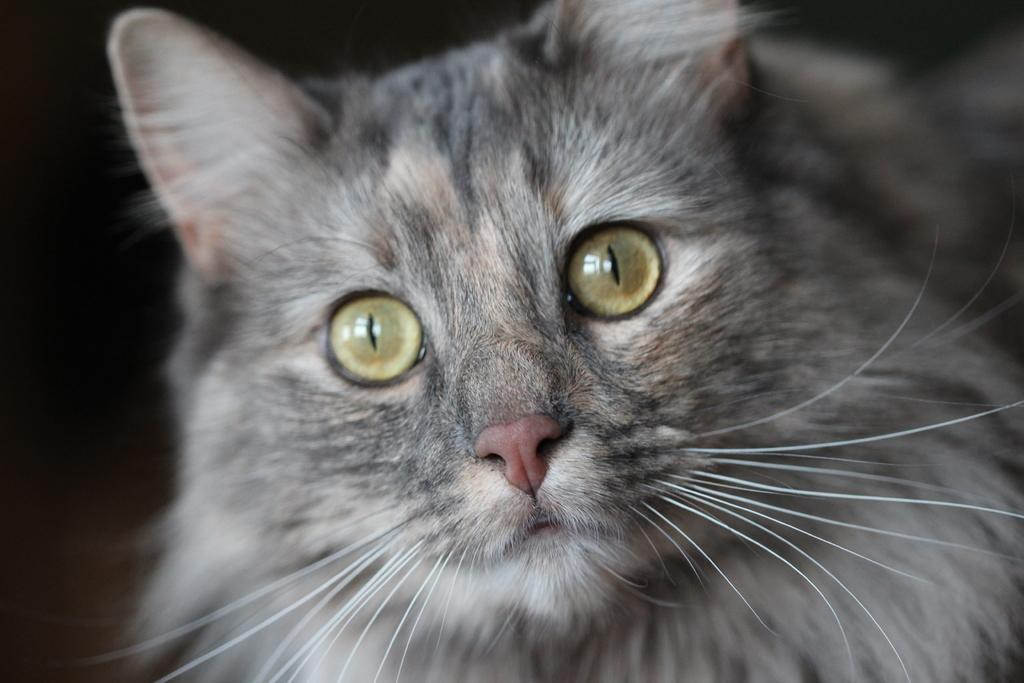What type of animal is in the picture? There is a cat in the picture. What color is the cat? The cat is gray in color, with some parts being white. What type of watch is the cat wearing in the picture? There is no watch present in the picture; the cat is not wearing any accessories. 